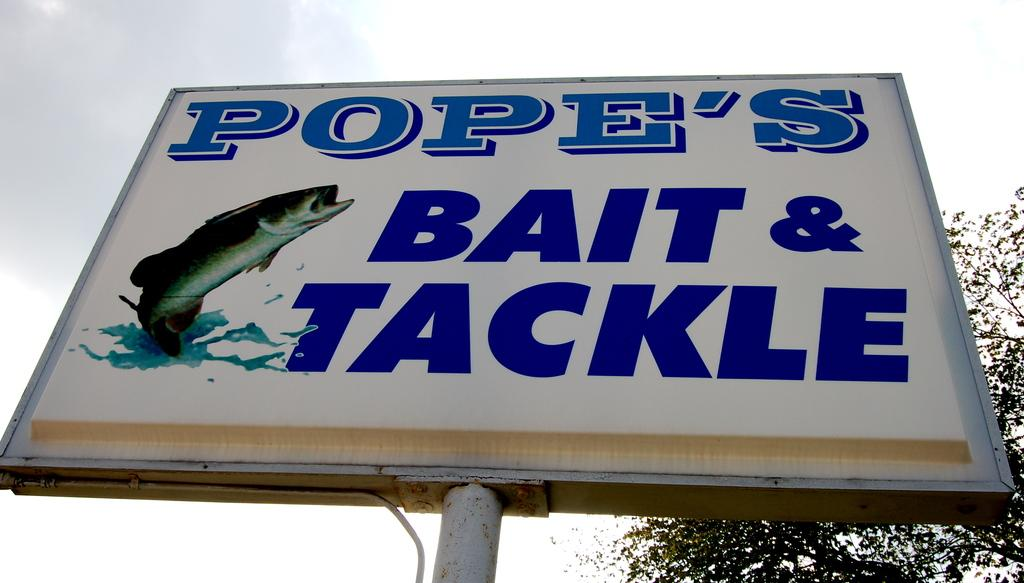What is the main subject in the image? There is a hoarding in the image. What can be seen behind the hoarding? There are trees visible behind the hoarding. What is visible in the sky in the image? There are clouds in the sky. What part of the natural environment is visible in the image? The sky is visible in the image. How many trays of milk can be seen on the hoarding in the image? There are no trays or milk present on the hoarding in the image. What type of lizards are crawling on the trees behind the hoarding? There are no lizards visible on the trees behind the hoarding in the image. 